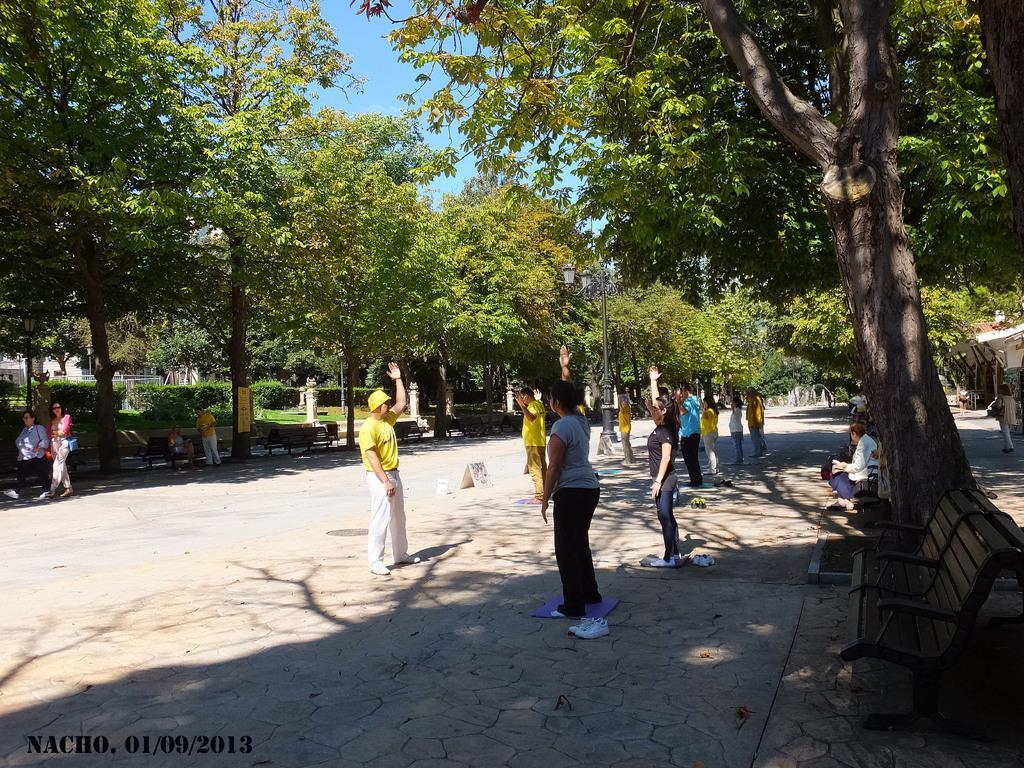Please provide a concise description of this image. In this image there is a road on which there are there are few people who are doing the exercise. There are trees on either side of the road. 